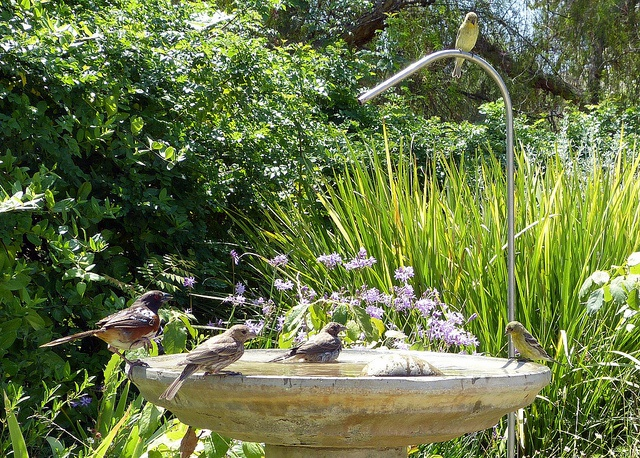Describe the objects in this image and their specific colors. I can see bird in darkgreen, black, gray, maroon, and lightgray tones, bird in darkgreen, gray, ivory, and darkgray tones, bird in darkgreen, gray, ivory, black, and darkgray tones, bird in darkgreen, olive, and gray tones, and bird in darkgreen, olive, gray, and darkgray tones in this image. 